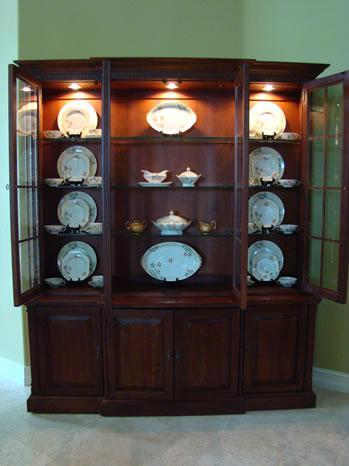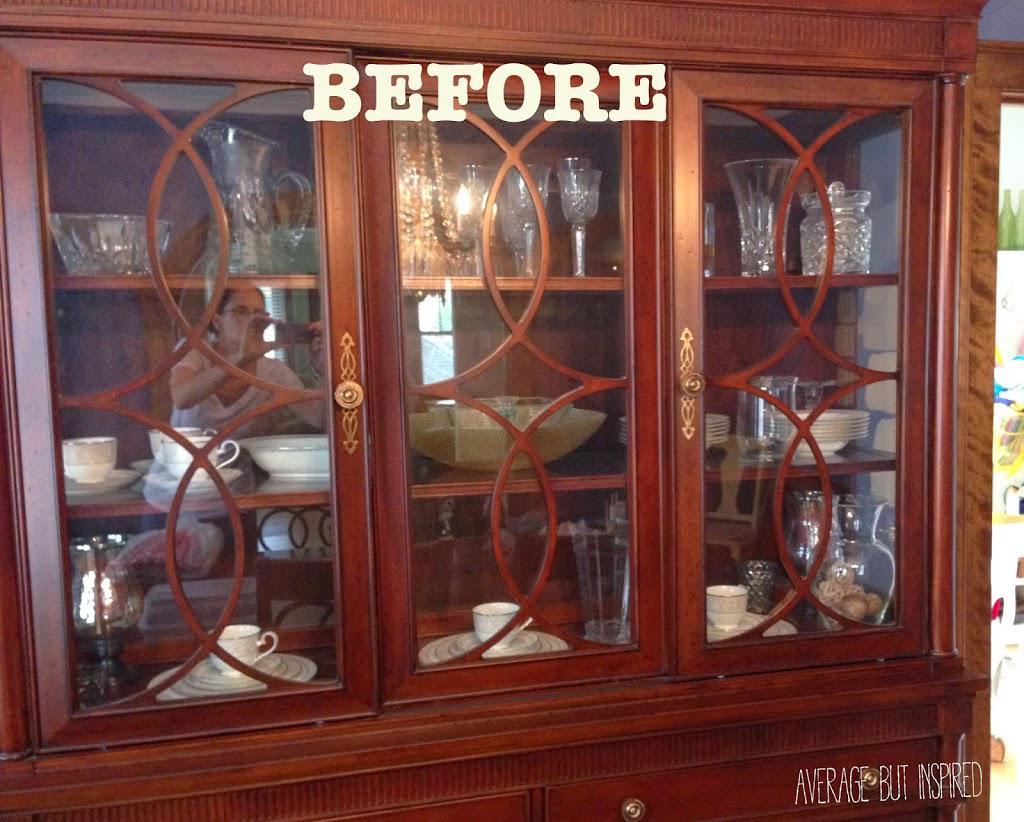The first image is the image on the left, the second image is the image on the right. Evaluate the accuracy of this statement regarding the images: "There are four plates on each shelf in the image on the left". Is it true? Answer yes or no. No. The first image is the image on the left, the second image is the image on the right. Analyze the images presented: Is the assertion "There is one hutch with doors open." valid? Answer yes or no. Yes. 